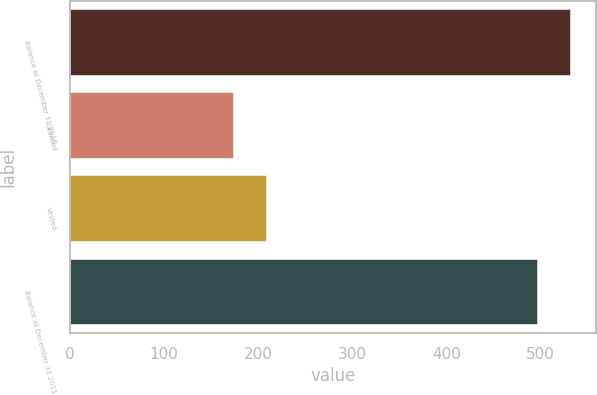Convert chart to OTSL. <chart><loc_0><loc_0><loc_500><loc_500><bar_chart><fcel>Balance at December 31 2010<fcel>Granted<fcel>Vested<fcel>Balance at December 31 2011<nl><fcel>532.1<fcel>174<fcel>209.1<fcel>497<nl></chart> 